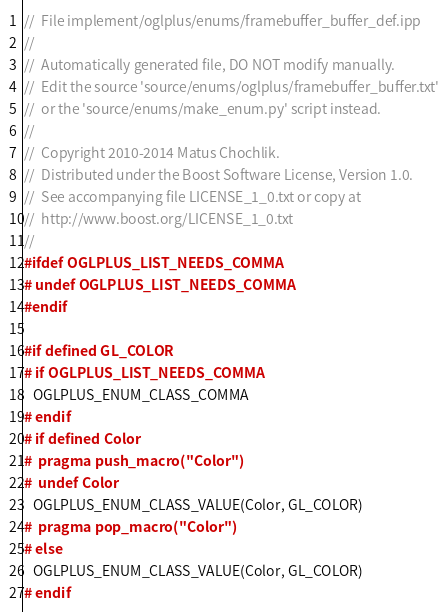<code> <loc_0><loc_0><loc_500><loc_500><_C++_>//  File implement/oglplus/enums/framebuffer_buffer_def.ipp
//
//  Automatically generated file, DO NOT modify manually.
//  Edit the source 'source/enums/oglplus/framebuffer_buffer.txt'
//  or the 'source/enums/make_enum.py' script instead.
//
//  Copyright 2010-2014 Matus Chochlik.
//  Distributed under the Boost Software License, Version 1.0.
//  See accompanying file LICENSE_1_0.txt or copy at
//  http://www.boost.org/LICENSE_1_0.txt
//
#ifdef OGLPLUS_LIST_NEEDS_COMMA
# undef OGLPLUS_LIST_NEEDS_COMMA
#endif

#if defined GL_COLOR
# if OGLPLUS_LIST_NEEDS_COMMA
   OGLPLUS_ENUM_CLASS_COMMA
# endif
# if defined Color
#  pragma push_macro("Color")
#  undef Color
   OGLPLUS_ENUM_CLASS_VALUE(Color, GL_COLOR)
#  pragma pop_macro("Color")
# else
   OGLPLUS_ENUM_CLASS_VALUE(Color, GL_COLOR)
# endif</code> 